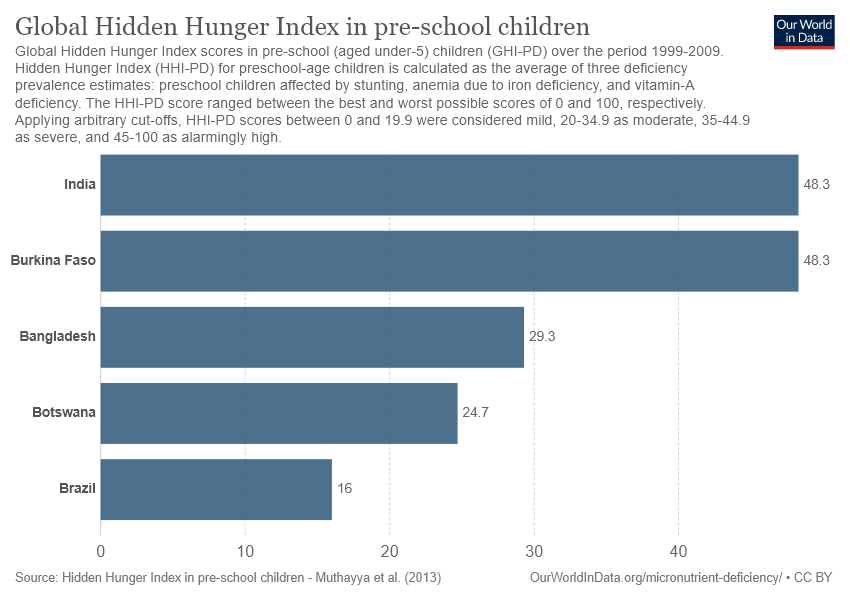Mention a couple of crucial points in this snapshot. The average of the bottom three countries is 23.3. The value of the largest bar is 48.3. 